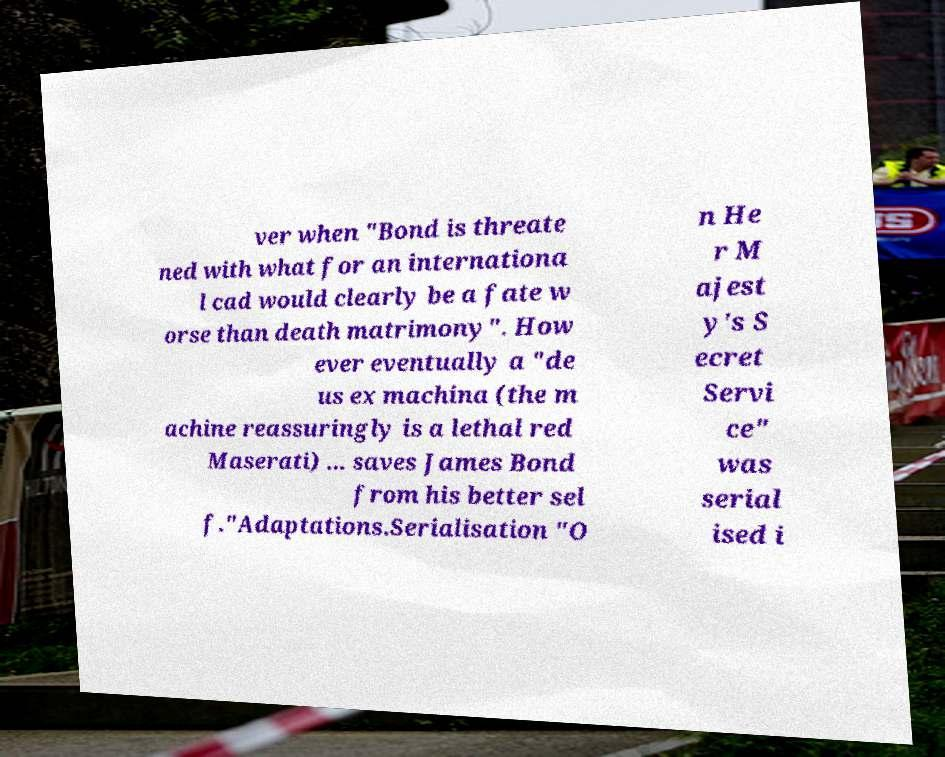There's text embedded in this image that I need extracted. Can you transcribe it verbatim? ver when "Bond is threate ned with what for an internationa l cad would clearly be a fate w orse than death matrimony". How ever eventually a "de us ex machina (the m achine reassuringly is a lethal red Maserati) ... saves James Bond from his better sel f."Adaptations.Serialisation "O n He r M ajest y's S ecret Servi ce" was serial ised i 